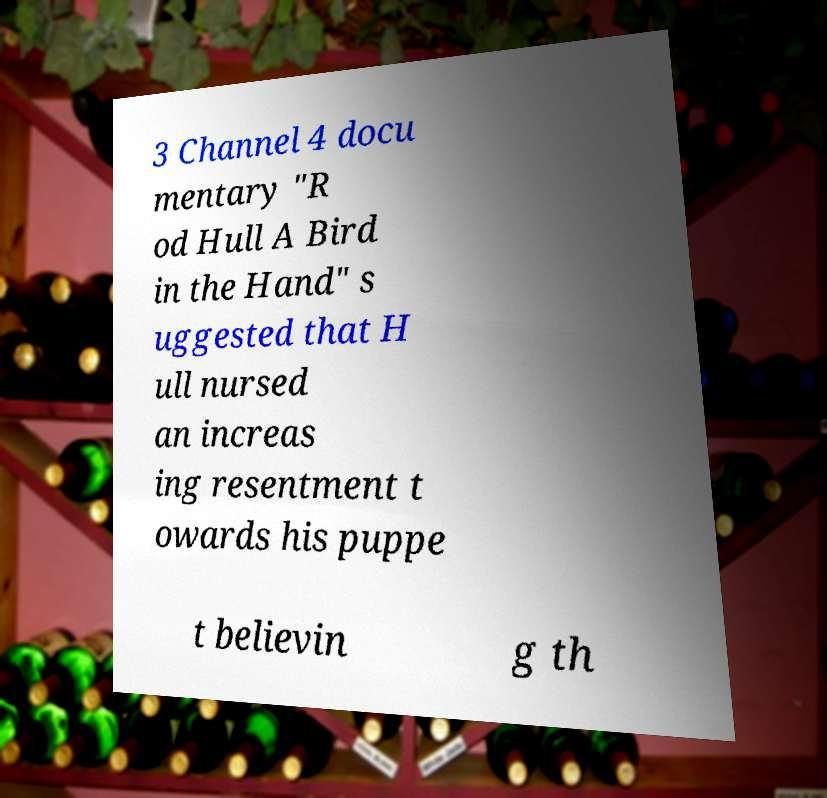There's text embedded in this image that I need extracted. Can you transcribe it verbatim? 3 Channel 4 docu mentary "R od Hull A Bird in the Hand" s uggested that H ull nursed an increas ing resentment t owards his puppe t believin g th 